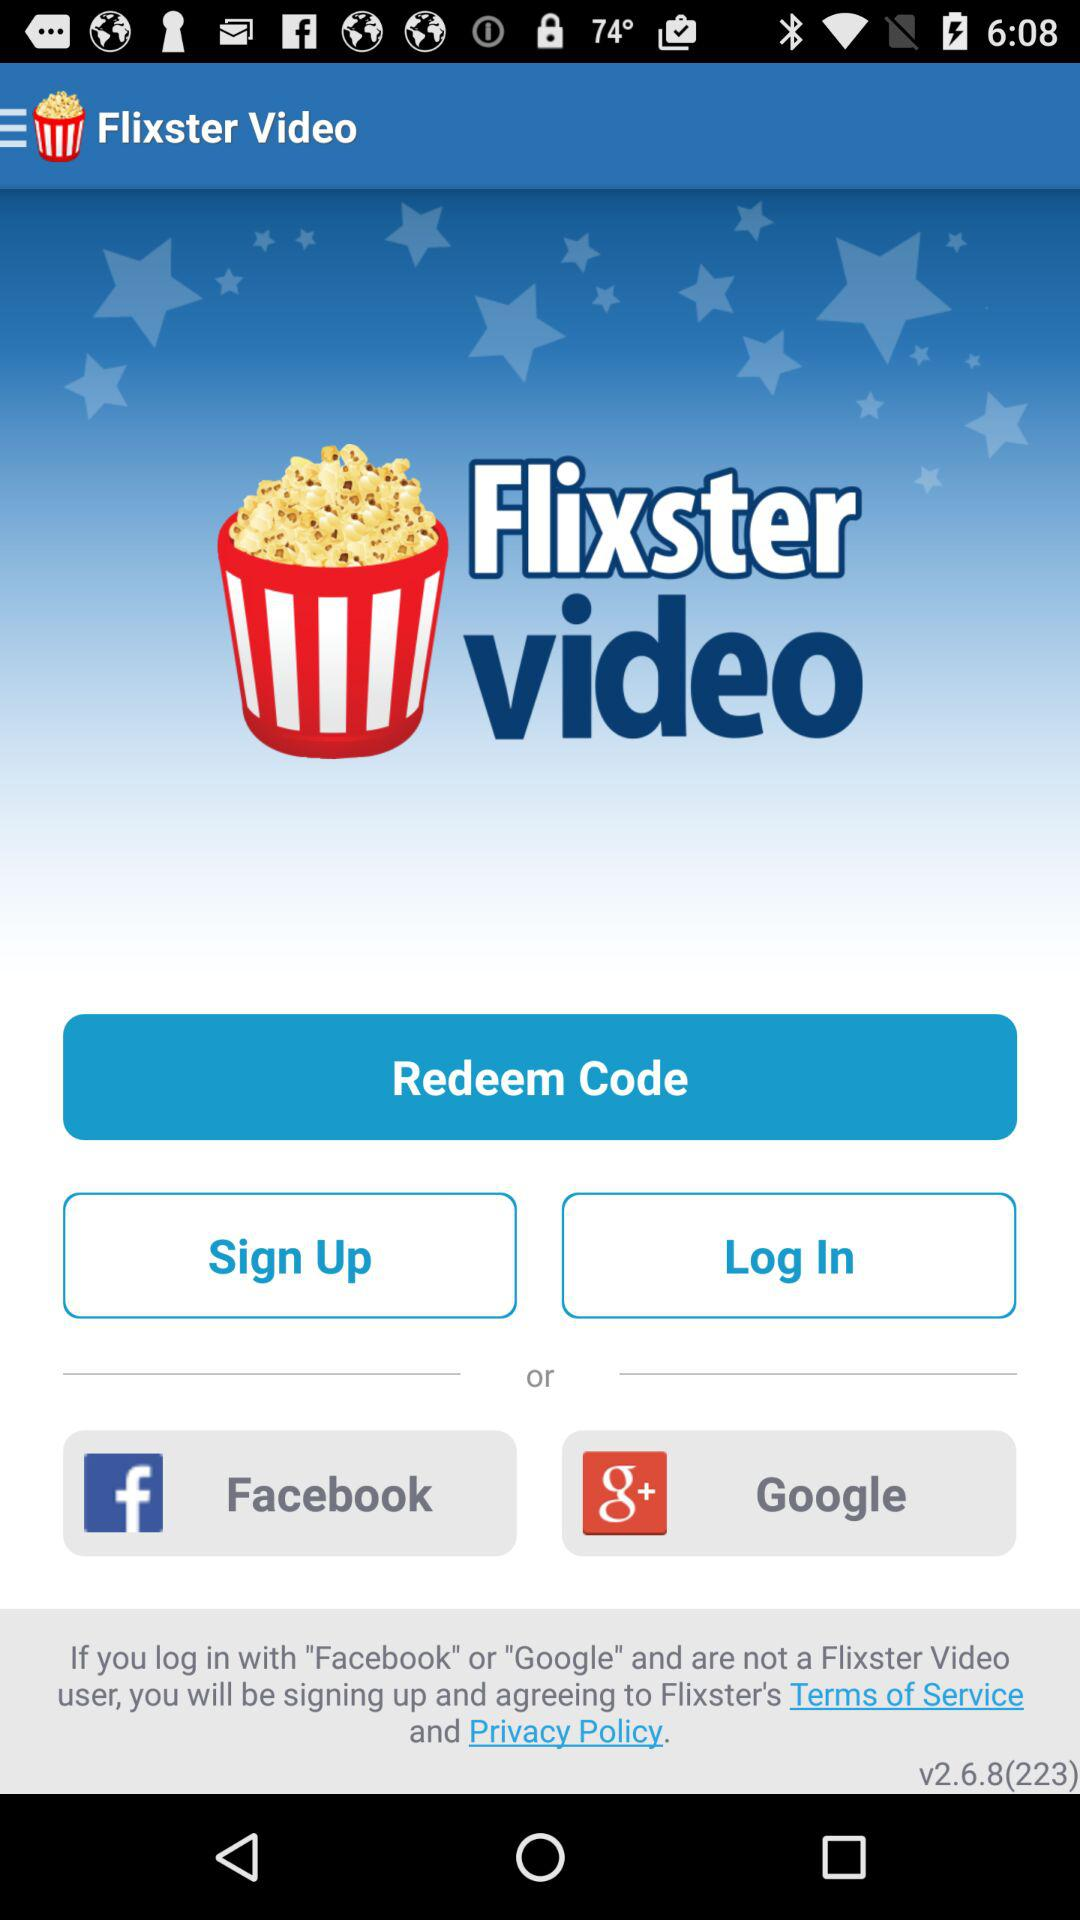What is the version of the application being used? The version of the application is v2.6.8 (223). 